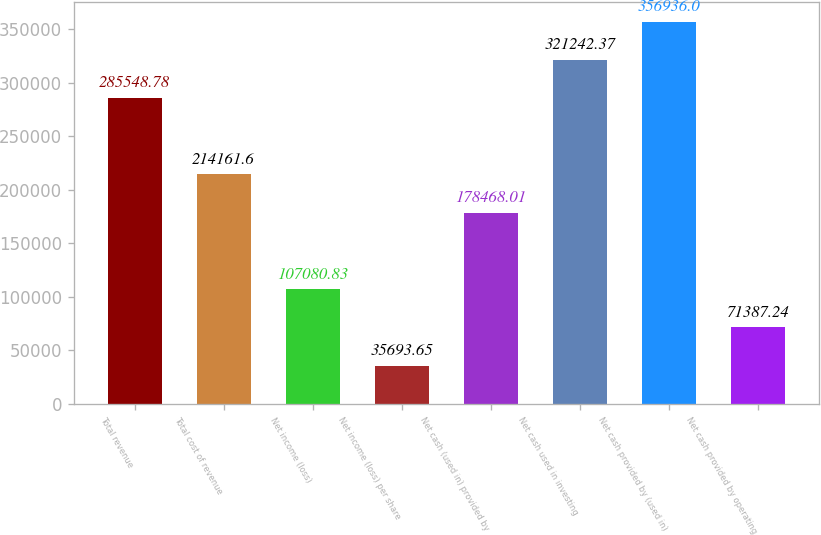<chart> <loc_0><loc_0><loc_500><loc_500><bar_chart><fcel>Total revenue<fcel>Total cost of revenue<fcel>Net income (loss)<fcel>Net income (loss) per share<fcel>Net cash (used in) provided by<fcel>Net cash used in investing<fcel>Net cash provided by (used in)<fcel>Net cash provided by operating<nl><fcel>285549<fcel>214162<fcel>107081<fcel>35693.7<fcel>178468<fcel>321242<fcel>356936<fcel>71387.2<nl></chart> 